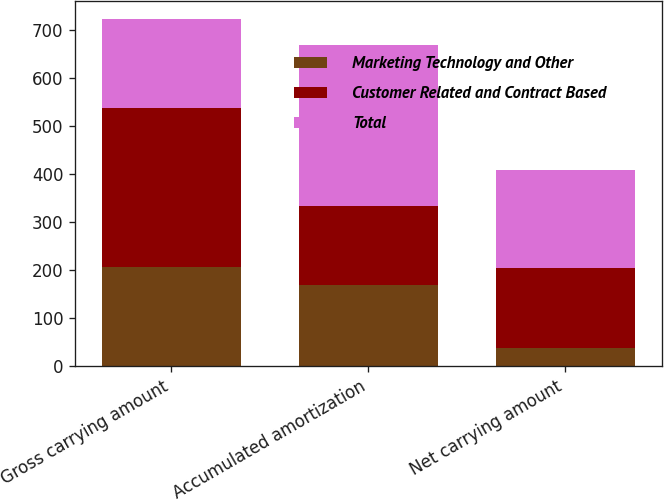<chart> <loc_0><loc_0><loc_500><loc_500><stacked_bar_chart><ecel><fcel>Gross carrying amount<fcel>Accumulated amortization<fcel>Net carrying amount<nl><fcel>Marketing Technology and Other<fcel>206<fcel>168<fcel>38<nl><fcel>Customer Related and Contract Based<fcel>332<fcel>166<fcel>166<nl><fcel>Total<fcel>186<fcel>334<fcel>204<nl></chart> 